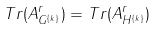<formula> <loc_0><loc_0><loc_500><loc_500>T r ( A _ { G ^ { \{ k \} } } ^ { r } ) = T r ( A _ { H ^ { \{ k \} } } ^ { r } )</formula> 